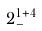Convert formula to latex. <formula><loc_0><loc_0><loc_500><loc_500>2 _ { - } ^ { 1 + 4 }</formula> 